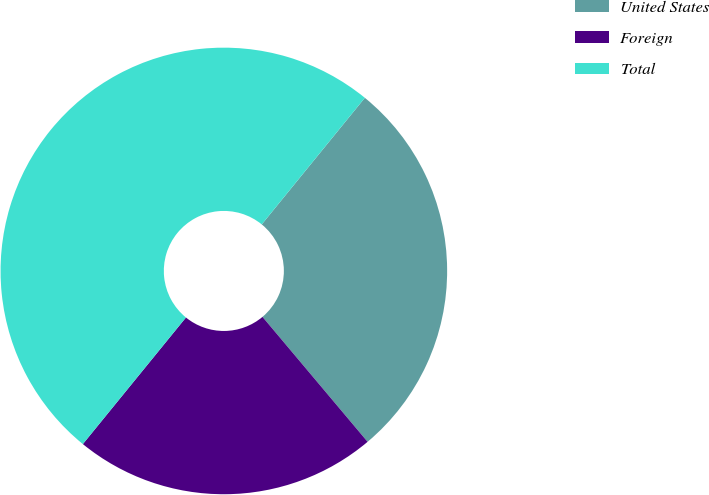Convert chart. <chart><loc_0><loc_0><loc_500><loc_500><pie_chart><fcel>United States<fcel>Foreign<fcel>Total<nl><fcel>27.99%<fcel>22.01%<fcel>50.0%<nl></chart> 